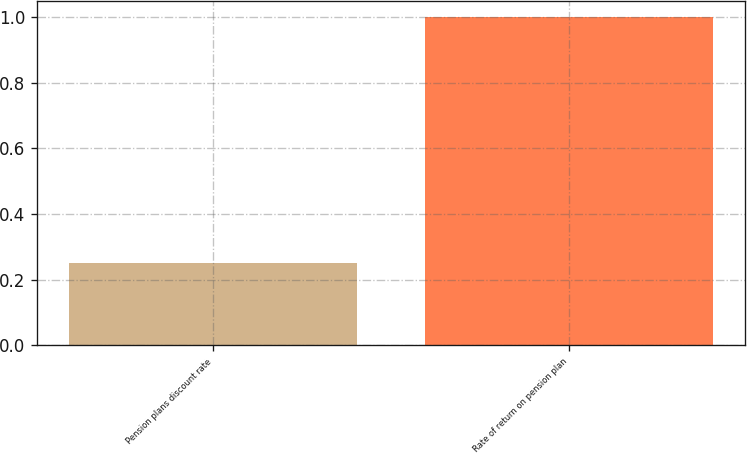Convert chart. <chart><loc_0><loc_0><loc_500><loc_500><bar_chart><fcel>Pension plans discount rate<fcel>Rate of return on pension plan<nl><fcel>0.25<fcel>1<nl></chart> 